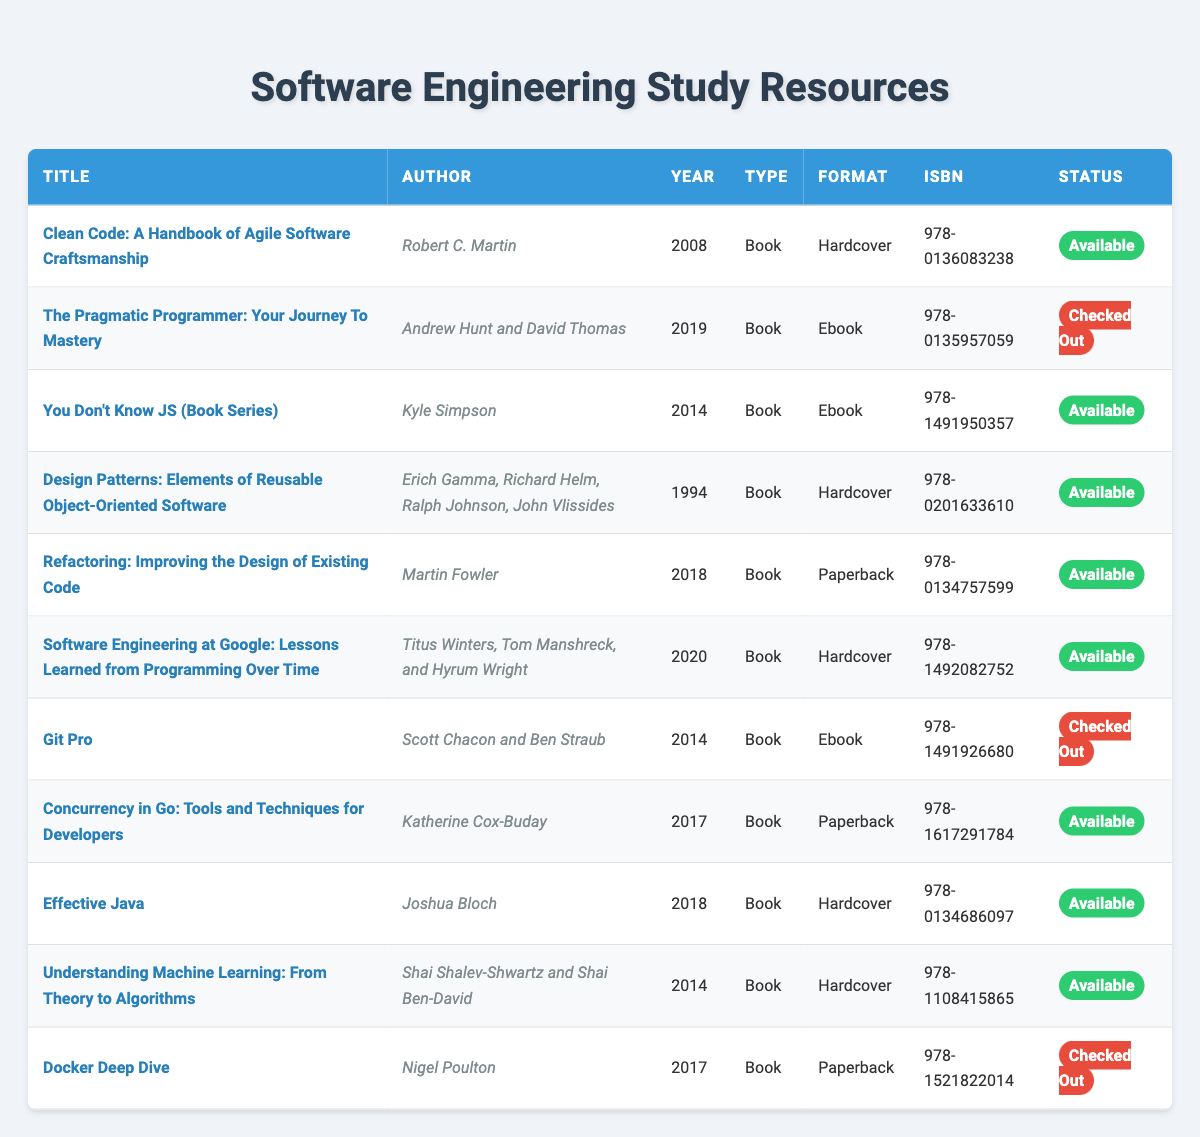What is the title of the book authored by Robert C. Martin? The table lists a book titled "Clean Code: A Handbook of Agile Software Craftsmanship" under the author Robert C. Martin.
Answer: Clean Code: A Handbook of Agile Software Craftsmanship How many books are currently checked out? There are three titles listed under the status "Checked Out," specifically: "The Pragmatic Programmer," "Git Pro," and "Docker Deep Dive."
Answer: 3 Which book was published the earliest in the table? The earliest publication year in the table is 1994, corresponding to the book "Design Patterns: Elements of Reusable Object-Oriented Software."
Answer: Design Patterns: Elements of Reusable Object-Oriented Software What percentage of the books in the inventory are available? There are 11 books total, with 8 available (excluding the 3 checked out). The percentage is calculated as (8/11) * 100 = 72.73%.
Answer: 72.73% Is "Effective Java" available for checkout? The status for "Effective Java" in the table indicates it is marked as "Available."
Answer: Yes How many different formats of books are listed in the inventory? The table shows three distinct formats: hardcover, paperback, and ebook. Hence, there are three different formats.
Answer: 3 Which authors have books that are currently available? The authors of the available books include Robert C. Martin, Kyle Simpson, Martin Fowler, Titus Winters, Tom Manshreck, Hyrum Wright, Katherine Cox-Buday, Joshua Bloch, and Shai Shalev-Shwartz. There are eight different authors in total for available titles.
Answer: 8 Are there any books regarding Docker in the inventory? The table includes "Docker Deep Dive" which is specifically focused on Docker, confirming the presence of a Docker-related book.
Answer: Yes What is the average publication year of the available books? The publication years of the available books are: 2008, 2014, 2018, 2020, 2017, 2018, 2014. The average is calculated as (2008 + 2014 + 2018 + 2020 + 2017 + 2018 + 2014) / 7, which equals approximately 2016.
Answer: 2016 